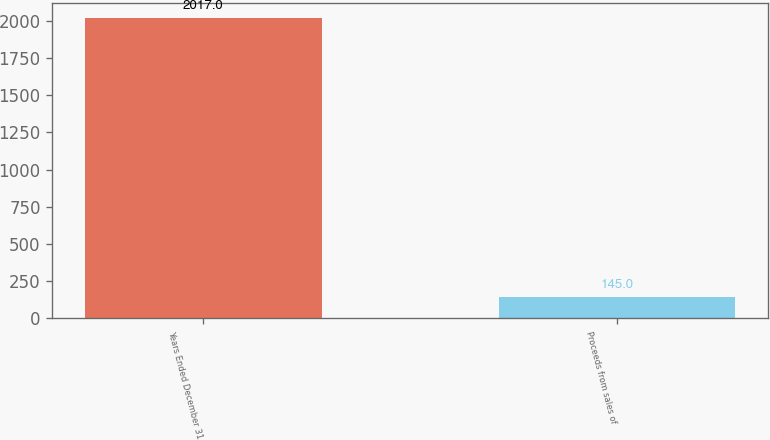Convert chart to OTSL. <chart><loc_0><loc_0><loc_500><loc_500><bar_chart><fcel>Years Ended December 31<fcel>Proceeds from sales of<nl><fcel>2017<fcel>145<nl></chart> 